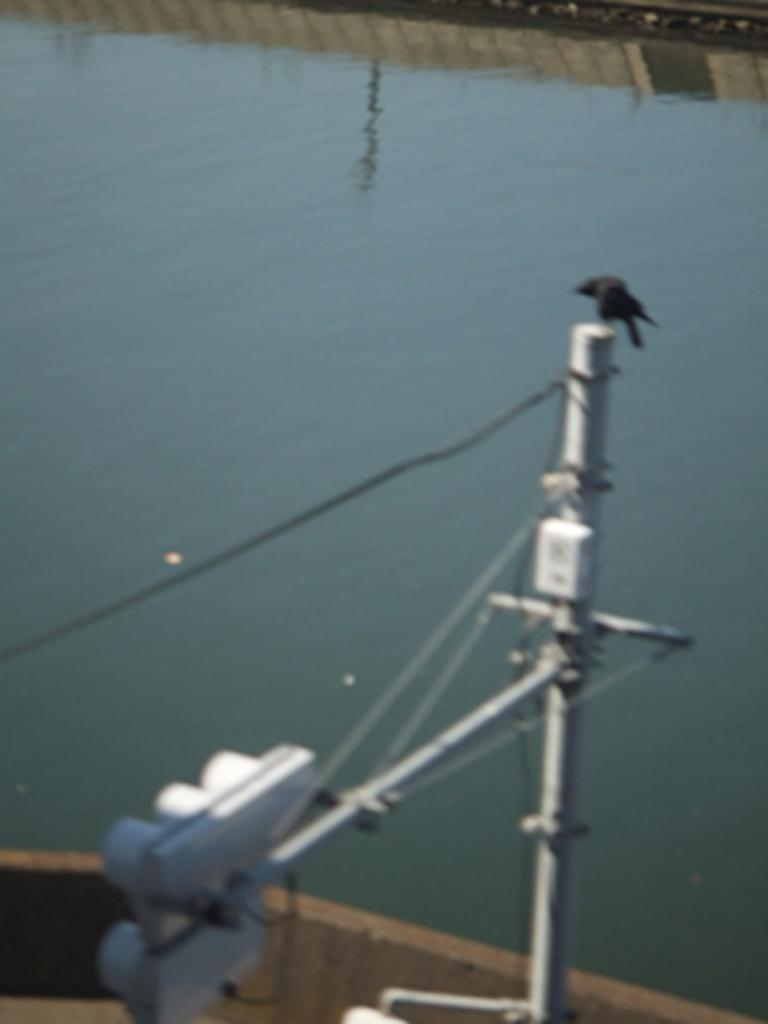What is the main structure in the image? There is a pole in the image. What else can be seen in the image besides the pole? There are wires and a wall visible in the image. What natural element is present in the image? There is water visible in the image. What is the woman doing with her ear in the image? There is no woman or ear present in the image. 